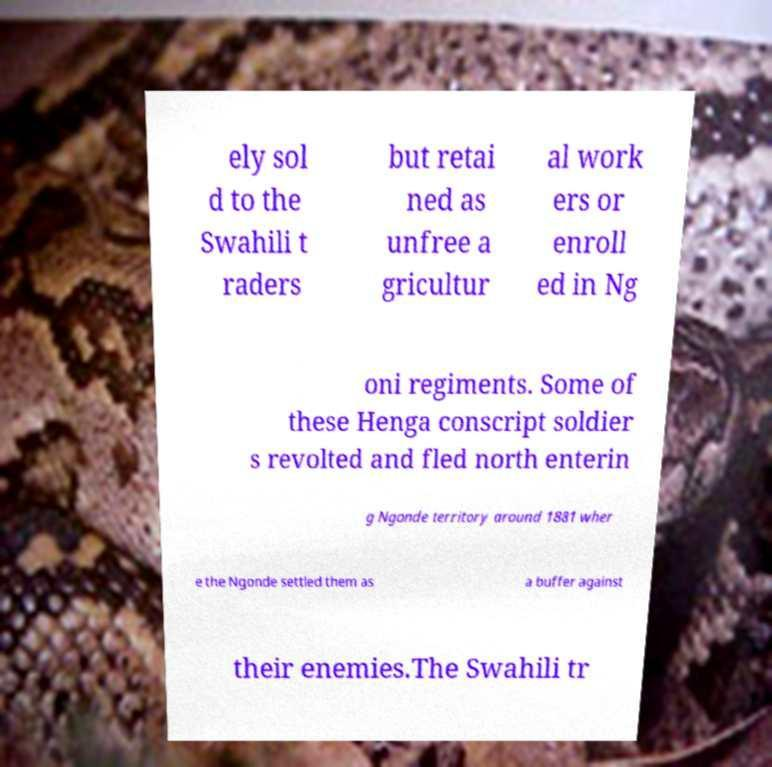Can you read and provide the text displayed in the image?This photo seems to have some interesting text. Can you extract and type it out for me? ely sol d to the Swahili t raders but retai ned as unfree a gricultur al work ers or enroll ed in Ng oni regiments. Some of these Henga conscript soldier s revolted and fled north enterin g Ngonde territory around 1881 wher e the Ngonde settled them as a buffer against their enemies.The Swahili tr 